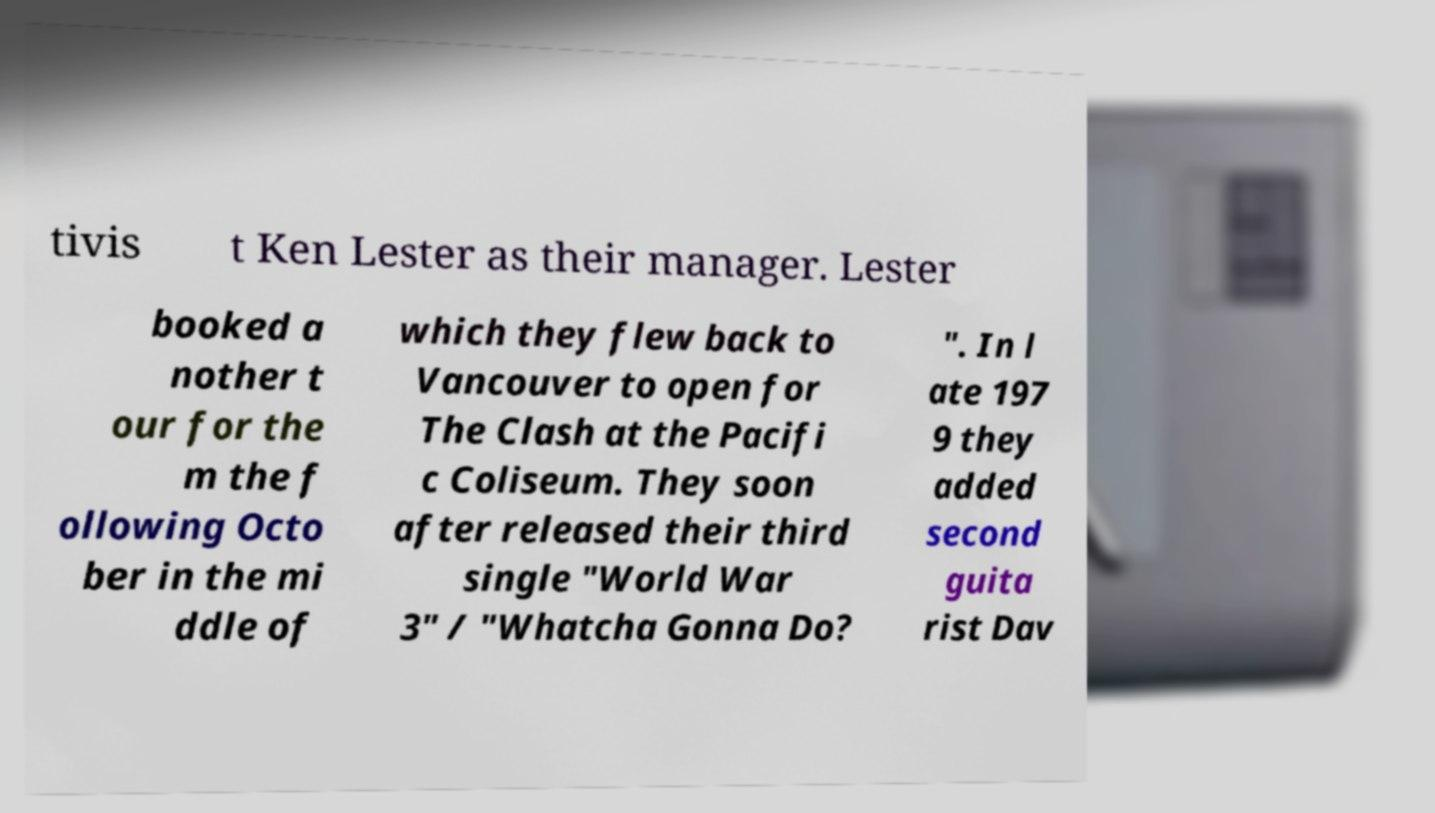For documentation purposes, I need the text within this image transcribed. Could you provide that? tivis t Ken Lester as their manager. Lester booked a nother t our for the m the f ollowing Octo ber in the mi ddle of which they flew back to Vancouver to open for The Clash at the Pacifi c Coliseum. They soon after released their third single "World War 3" / "Whatcha Gonna Do? ". In l ate 197 9 they added second guita rist Dav 